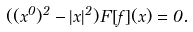Convert formula to latex. <formula><loc_0><loc_0><loc_500><loc_500>( ( x ^ { 0 } ) ^ { 2 } - | { x } | ^ { 2 } ) F [ f ] ( x ) = 0 .</formula> 